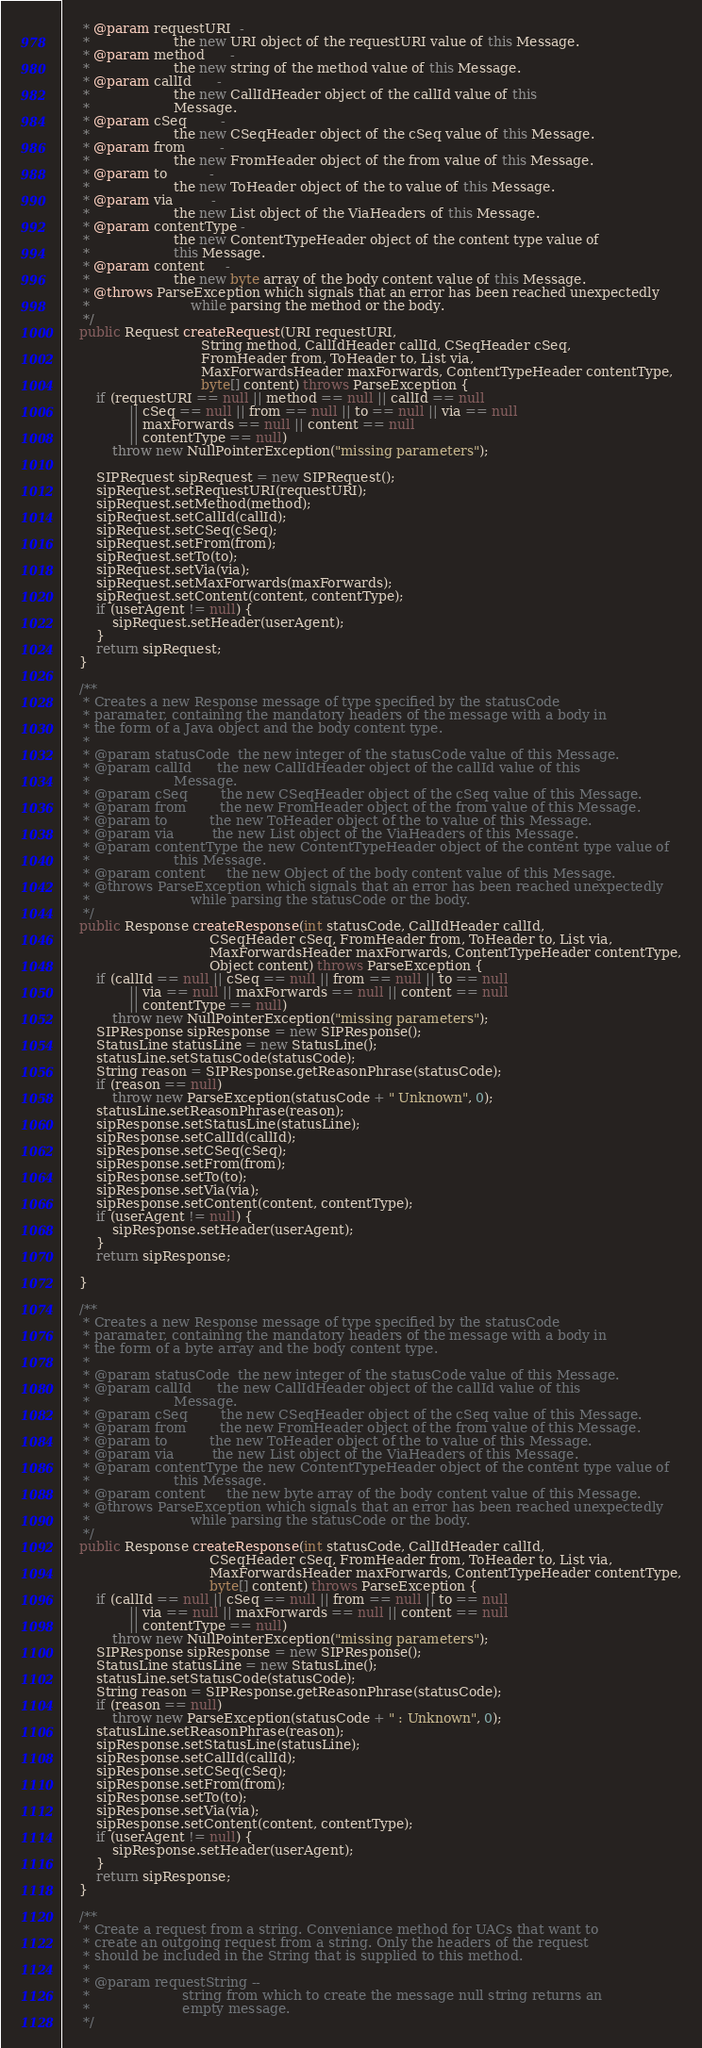<code> <loc_0><loc_0><loc_500><loc_500><_Java_>     * @param requestURI  -
     *                    the new URI object of the requestURI value of this Message.
     * @param method      -
     *                    the new string of the method value of this Message.
     * @param callId      -
     *                    the new CallIdHeader object of the callId value of this
     *                    Message.
     * @param cSeq        -
     *                    the new CSeqHeader object of the cSeq value of this Message.
     * @param from        -
     *                    the new FromHeader object of the from value of this Message.
     * @param to          -
     *                    the new ToHeader object of the to value of this Message.
     * @param via         -
     *                    the new List object of the ViaHeaders of this Message.
     * @param contentType -
     *                    the new ContentTypeHeader object of the content type value of
     *                    this Message.
     * @param content     -
     *                    the new byte array of the body content value of this Message.
     * @throws ParseException which signals that an error has been reached unexpectedly
     *                        while parsing the method or the body.
     */
    public Request createRequest(URI requestURI,
                                 String method, CallIdHeader callId, CSeqHeader cSeq,
                                 FromHeader from, ToHeader to, List via,
                                 MaxForwardsHeader maxForwards, ContentTypeHeader contentType,
                                 byte[] content) throws ParseException {
        if (requestURI == null || method == null || callId == null
                || cSeq == null || from == null || to == null || via == null
                || maxForwards == null || content == null
                || contentType == null)
            throw new NullPointerException("missing parameters");

        SIPRequest sipRequest = new SIPRequest();
        sipRequest.setRequestURI(requestURI);
        sipRequest.setMethod(method);
        sipRequest.setCallId(callId);
        sipRequest.setCSeq(cSeq);
        sipRequest.setFrom(from);
        sipRequest.setTo(to);
        sipRequest.setVia(via);
        sipRequest.setMaxForwards(maxForwards);
        sipRequest.setContent(content, contentType);
        if (userAgent != null) {
            sipRequest.setHeader(userAgent);
        }
        return sipRequest;
    }

    /**
     * Creates a new Response message of type specified by the statusCode
     * paramater, containing the mandatory headers of the message with a body in
     * the form of a Java object and the body content type.
     *
     * @param statusCode  the new integer of the statusCode value of this Message.
     * @param callId      the new CallIdHeader object of the callId value of this
     *                    Message.
     * @param cSeq        the new CSeqHeader object of the cSeq value of this Message.
     * @param from        the new FromHeader object of the from value of this Message.
     * @param to          the new ToHeader object of the to value of this Message.
     * @param via         the new List object of the ViaHeaders of this Message.
     * @param contentType the new ContentTypeHeader object of the content type value of
     *                    this Message.
     * @param content     the new Object of the body content value of this Message.
     * @throws ParseException which signals that an error has been reached unexpectedly
     *                        while parsing the statusCode or the body.
     */
    public Response createResponse(int statusCode, CallIdHeader callId,
                                   CSeqHeader cSeq, FromHeader from, ToHeader to, List via,
                                   MaxForwardsHeader maxForwards, ContentTypeHeader contentType,
                                   Object content) throws ParseException {
        if (callId == null || cSeq == null || from == null || to == null
                || via == null || maxForwards == null || content == null
                || contentType == null)
            throw new NullPointerException("missing parameters");
        SIPResponse sipResponse = new SIPResponse();
        StatusLine statusLine = new StatusLine();
        statusLine.setStatusCode(statusCode);
        String reason = SIPResponse.getReasonPhrase(statusCode);
        if (reason == null)
            throw new ParseException(statusCode + " Unknown", 0);
        statusLine.setReasonPhrase(reason);
        sipResponse.setStatusLine(statusLine);
        sipResponse.setCallId(callId);
        sipResponse.setCSeq(cSeq);
        sipResponse.setFrom(from);
        sipResponse.setTo(to);
        sipResponse.setVia(via);
        sipResponse.setContent(content, contentType);
        if (userAgent != null) {
            sipResponse.setHeader(userAgent);
        }
        return sipResponse;

    }

    /**
     * Creates a new Response message of type specified by the statusCode
     * paramater, containing the mandatory headers of the message with a body in
     * the form of a byte array and the body content type.
     *
     * @param statusCode  the new integer of the statusCode value of this Message.
     * @param callId      the new CallIdHeader object of the callId value of this
     *                    Message.
     * @param cSeq        the new CSeqHeader object of the cSeq value of this Message.
     * @param from        the new FromHeader object of the from value of this Message.
     * @param to          the new ToHeader object of the to value of this Message.
     * @param via         the new List object of the ViaHeaders of this Message.
     * @param contentType the new ContentTypeHeader object of the content type value of
     *                    this Message.
     * @param content     the new byte array of the body content value of this Message.
     * @throws ParseException which signals that an error has been reached unexpectedly
     *                        while parsing the statusCode or the body.
     */
    public Response createResponse(int statusCode, CallIdHeader callId,
                                   CSeqHeader cSeq, FromHeader from, ToHeader to, List via,
                                   MaxForwardsHeader maxForwards, ContentTypeHeader contentType,
                                   byte[] content) throws ParseException {
        if (callId == null || cSeq == null || from == null || to == null
                || via == null || maxForwards == null || content == null
                || contentType == null)
            throw new NullPointerException("missing parameters");
        SIPResponse sipResponse = new SIPResponse();
        StatusLine statusLine = new StatusLine();
        statusLine.setStatusCode(statusCode);
        String reason = SIPResponse.getReasonPhrase(statusCode);
        if (reason == null)
            throw new ParseException(statusCode + " : Unknown", 0);
        statusLine.setReasonPhrase(reason);
        sipResponse.setStatusLine(statusLine);
        sipResponse.setCallId(callId);
        sipResponse.setCSeq(cSeq);
        sipResponse.setFrom(from);
        sipResponse.setTo(to);
        sipResponse.setVia(via);
        sipResponse.setContent(content, contentType);
        if (userAgent != null) {
            sipResponse.setHeader(userAgent);
        }
        return sipResponse;
    }

    /**
     * Create a request from a string. Conveniance method for UACs that want to
     * create an outgoing request from a string. Only the headers of the request
     * should be included in the String that is supplied to this method.
     *
     * @param requestString --
     *                      string from which to create the message null string returns an
     *                      empty message.
     */</code> 